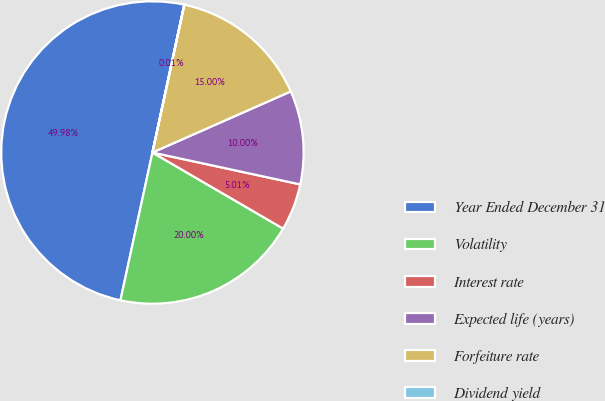<chart> <loc_0><loc_0><loc_500><loc_500><pie_chart><fcel>Year Ended December 31<fcel>Volatility<fcel>Interest rate<fcel>Expected life (years)<fcel>Forfeiture rate<fcel>Dividend yield<nl><fcel>49.98%<fcel>20.0%<fcel>5.01%<fcel>10.0%<fcel>15.0%<fcel>0.01%<nl></chart> 